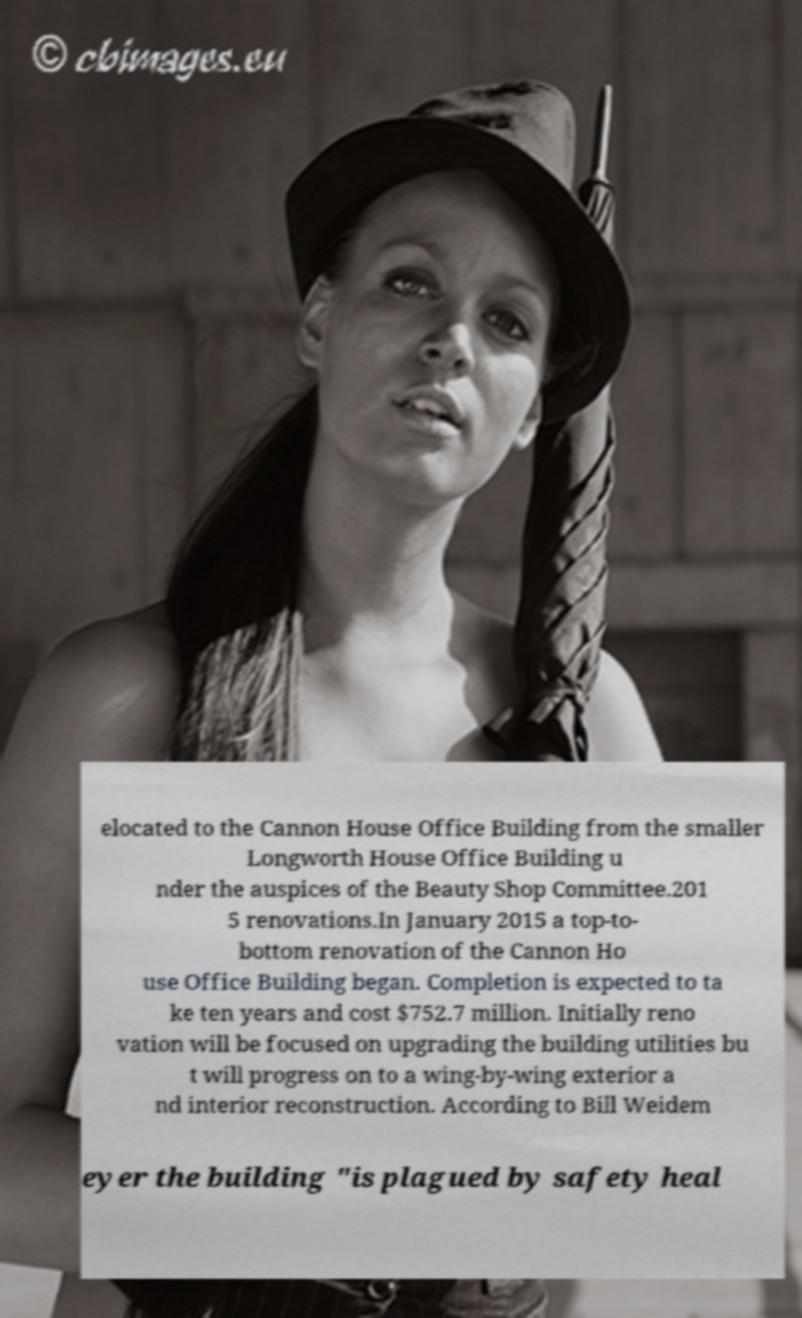I need the written content from this picture converted into text. Can you do that? elocated to the Cannon House Office Building from the smaller Longworth House Office Building u nder the auspices of the Beauty Shop Committee.201 5 renovations.In January 2015 a top-to- bottom renovation of the Cannon Ho use Office Building began. Completion is expected to ta ke ten years and cost $752.7 million. Initially reno vation will be focused on upgrading the building utilities bu t will progress on to a wing-by-wing exterior a nd interior reconstruction. According to Bill Weidem eyer the building "is plagued by safety heal 